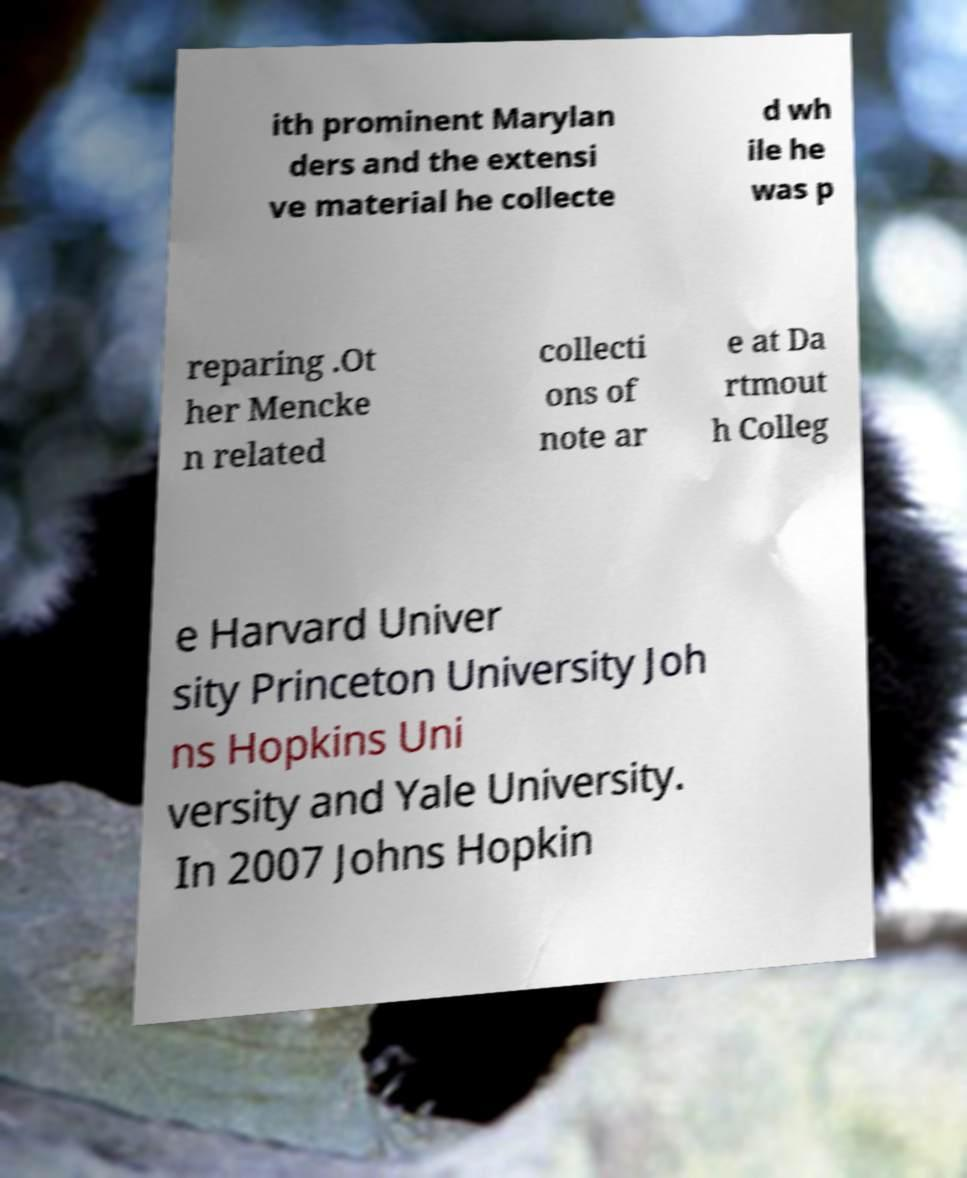Please read and relay the text visible in this image. What does it say? ith prominent Marylan ders and the extensi ve material he collecte d wh ile he was p reparing .Ot her Mencke n related collecti ons of note ar e at Da rtmout h Colleg e Harvard Univer sity Princeton University Joh ns Hopkins Uni versity and Yale University. In 2007 Johns Hopkin 